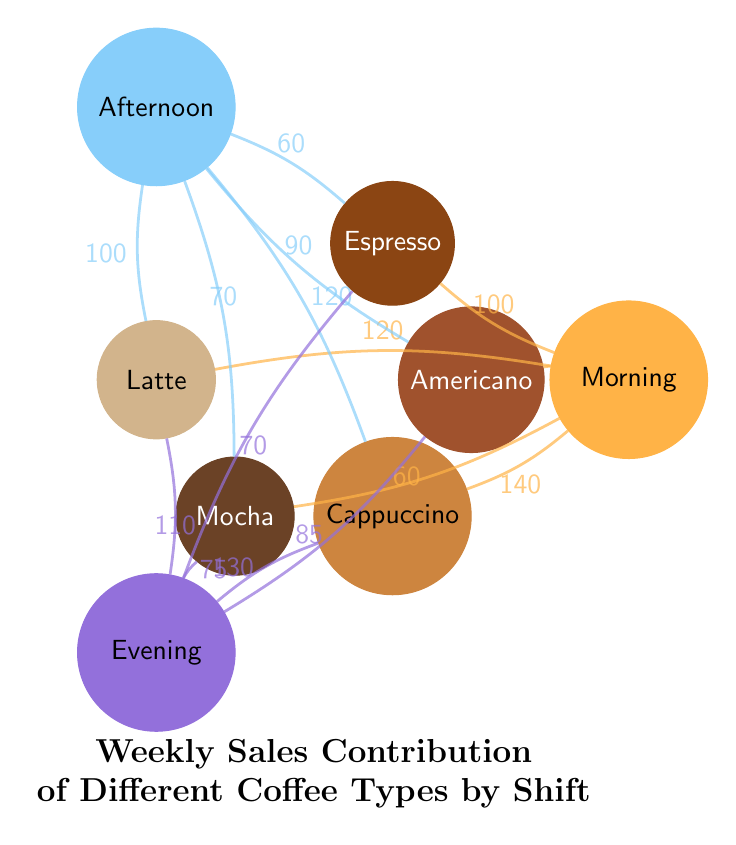What is the sales contribution of Cappuccino during the Morning shift? In the diagram, you can see a chord connecting the Morning node to the Cappuccino node. The label on that chord shows the sales contribution value for Cappuccino in the Morning. According to the diagram, that value is 140.
Answer: 140 Which coffee type has the highest sales contribution in the Afternoon shift? The diagram shows several chords connecting the Afternoon node to the coffee type nodes. To find the highest sales contribution, compare the values on the chords. The chord connecting Afternoon to Cappuccino has the highest value of 120.
Answer: Cappuccino How many coffee types are represented in this diagram? Count the number of coffee type nodes displayed around the center area of the diagram. There are five coffee type nodes: Espresso, Latte, Cappuccino, Americano, and Mocha.
Answer: 5 What is the sales contribution of Mocha during the Evening shift? Look for the chord connecting the Evening node to the Mocha node. The value associated with that chord indicates the sales contribution for Mocha during the Evening. The value is 75.
Answer: 75 Which shift contributes the most to Espresso sales overall? To find the total contribution of Espresso across all shifts, sum the values of the chords connected to the Espresso node: 100 (Morning) + 60 (Afternoon) + 70 (Evening) = 230. This total indicates that the shift with the highest sales contribution to Espresso is the Morning shift with 100.
Answer: Morning What is the sales contribution of Americano during the Afternoon shift? In the diagram, there is a chord connecting the Afternoon node to the Americano node. Looking at the label on that chord reveals the value for Americano sales during the Afternoon. The value is 90.
Answer: 90 Which coffee type has the least sales contribution during the Morning shift? Examine the values of the chords that connect the Morning node to the coffee type nodes. The lowest value indicates the least sales contribution. In this case, the lowest sales contribution is for Mocha with a value of 60.
Answer: Mocha How do the sales contributions for Latte compare between the Afternoon and Evening shifts? Look at the chords connecting the Latte node to both the Afternoon and Evening nodes. The value for Afternoon is 100 and for Evening it’s 110. Since 110 is greater than 100, the Evening shift has a higher contribution.
Answer: Evening 